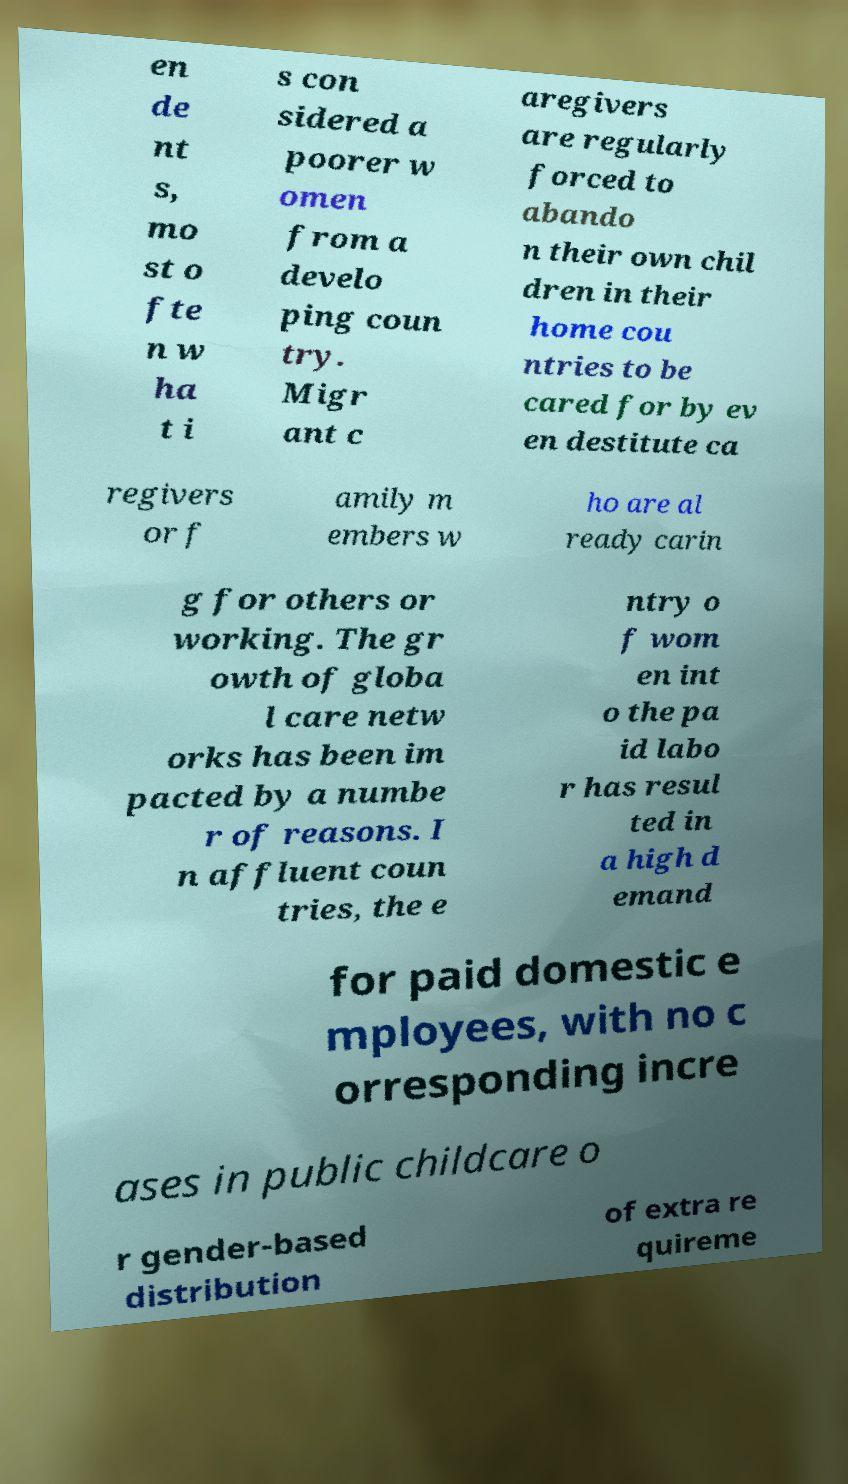I need the written content from this picture converted into text. Can you do that? en de nt s, mo st o fte n w ha t i s con sidered a poorer w omen from a develo ping coun try. Migr ant c aregivers are regularly forced to abando n their own chil dren in their home cou ntries to be cared for by ev en destitute ca regivers or f amily m embers w ho are al ready carin g for others or working. The gr owth of globa l care netw orks has been im pacted by a numbe r of reasons. I n affluent coun tries, the e ntry o f wom en int o the pa id labo r has resul ted in a high d emand for paid domestic e mployees, with no c orresponding incre ases in public childcare o r gender-based distribution of extra re quireme 